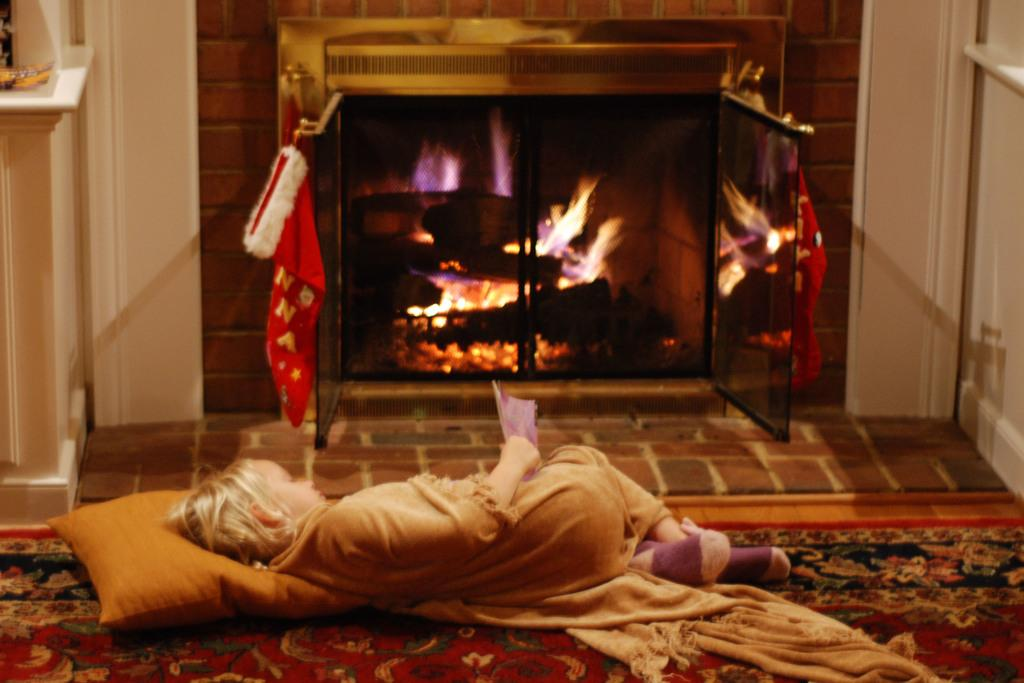Who is the main subject in the image? There is a girl in the image. What is the girl doing in the image? The girl is lying down. What is the girl holding in her hands? The girl is holding something in her hands, but we cannot determine what it is from the image. What is present near the girl in the image? There is a pillow in the image. What can be seen in the background of the image? There is a fireplace and other objects visible in the background of the image. What type of cork can be seen in the girl's hair in the image? There is no cork present in the girl's hair or anywhere else in the image. 